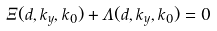<formula> <loc_0><loc_0><loc_500><loc_500>\Xi ( d , k _ { y } , k _ { 0 } ) + \Lambda ( d , k _ { y } , k _ { 0 } ) = 0</formula> 